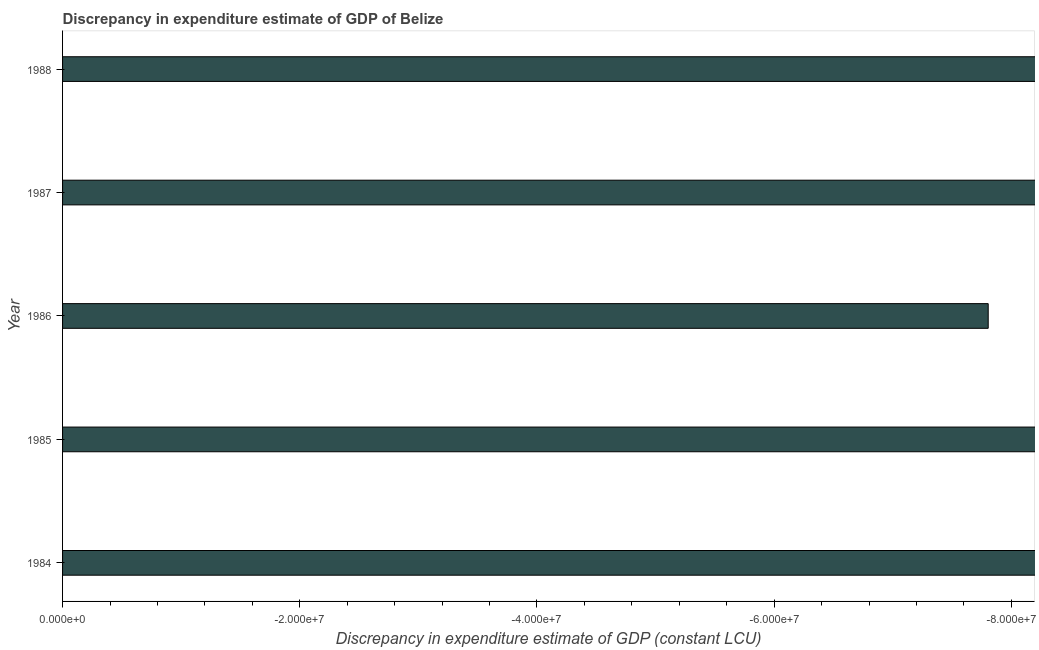Does the graph contain any zero values?
Ensure brevity in your answer.  Yes. What is the title of the graph?
Provide a succinct answer. Discrepancy in expenditure estimate of GDP of Belize. What is the label or title of the X-axis?
Your answer should be compact. Discrepancy in expenditure estimate of GDP (constant LCU). What is the discrepancy in expenditure estimate of gdp in 1988?
Your answer should be compact. 0. Across all years, what is the minimum discrepancy in expenditure estimate of gdp?
Give a very brief answer. 0. What is the average discrepancy in expenditure estimate of gdp per year?
Provide a succinct answer. 0. In how many years, is the discrepancy in expenditure estimate of gdp greater than the average discrepancy in expenditure estimate of gdp taken over all years?
Provide a succinct answer. 0. How many years are there in the graph?
Your response must be concise. 5. What is the difference between two consecutive major ticks on the X-axis?
Your response must be concise. 2.00e+07. What is the Discrepancy in expenditure estimate of GDP (constant LCU) in 1985?
Offer a terse response. 0. What is the Discrepancy in expenditure estimate of GDP (constant LCU) of 1987?
Provide a short and direct response. 0. 